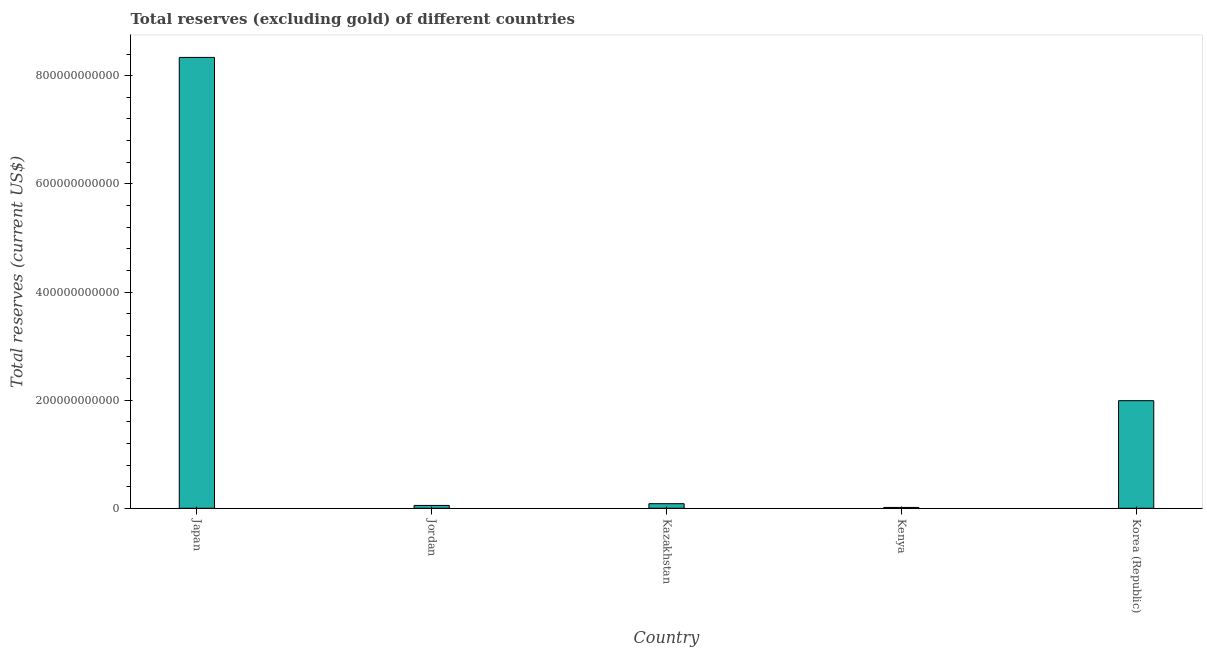Does the graph contain any zero values?
Provide a short and direct response. No. What is the title of the graph?
Offer a very short reply. Total reserves (excluding gold) of different countries. What is the label or title of the X-axis?
Provide a short and direct response. Country. What is the label or title of the Y-axis?
Offer a very short reply. Total reserves (current US$). What is the total reserves (excluding gold) in Jordan?
Make the answer very short. 5.27e+09. Across all countries, what is the maximum total reserves (excluding gold)?
Provide a short and direct response. 8.34e+11. Across all countries, what is the minimum total reserves (excluding gold)?
Offer a very short reply. 1.52e+09. In which country was the total reserves (excluding gold) minimum?
Your answer should be compact. Kenya. What is the sum of the total reserves (excluding gold)?
Provide a succinct answer. 1.05e+12. What is the difference between the total reserves (excluding gold) in Kazakhstan and Korea (Republic)?
Make the answer very short. -1.91e+11. What is the average total reserves (excluding gold) per country?
Give a very brief answer. 2.10e+11. What is the median total reserves (excluding gold)?
Give a very brief answer. 8.47e+09. In how many countries, is the total reserves (excluding gold) greater than 40000000000 US$?
Keep it short and to the point. 2. What is the ratio of the total reserves (excluding gold) in Kazakhstan to that in Korea (Republic)?
Provide a succinct answer. 0.04. What is the difference between the highest and the second highest total reserves (excluding gold)?
Keep it short and to the point. 6.35e+11. What is the difference between the highest and the lowest total reserves (excluding gold)?
Make the answer very short. 8.32e+11. How many bars are there?
Keep it short and to the point. 5. Are all the bars in the graph horizontal?
Make the answer very short. No. How many countries are there in the graph?
Offer a very short reply. 5. What is the difference between two consecutive major ticks on the Y-axis?
Your response must be concise. 2.00e+11. Are the values on the major ticks of Y-axis written in scientific E-notation?
Keep it short and to the point. No. What is the Total reserves (current US$) of Japan?
Give a very brief answer. 8.34e+11. What is the Total reserves (current US$) of Jordan?
Your answer should be compact. 5.27e+09. What is the Total reserves (current US$) of Kazakhstan?
Give a very brief answer. 8.47e+09. What is the Total reserves (current US$) in Kenya?
Provide a short and direct response. 1.52e+09. What is the Total reserves (current US$) in Korea (Republic)?
Offer a terse response. 1.99e+11. What is the difference between the Total reserves (current US$) in Japan and Jordan?
Keep it short and to the point. 8.29e+11. What is the difference between the Total reserves (current US$) in Japan and Kazakhstan?
Provide a succinct answer. 8.25e+11. What is the difference between the Total reserves (current US$) in Japan and Kenya?
Keep it short and to the point. 8.32e+11. What is the difference between the Total reserves (current US$) in Japan and Korea (Republic)?
Offer a terse response. 6.35e+11. What is the difference between the Total reserves (current US$) in Jordan and Kazakhstan?
Give a very brief answer. -3.21e+09. What is the difference between the Total reserves (current US$) in Jordan and Kenya?
Provide a succinct answer. 3.75e+09. What is the difference between the Total reserves (current US$) in Jordan and Korea (Republic)?
Your response must be concise. -1.94e+11. What is the difference between the Total reserves (current US$) in Kazakhstan and Kenya?
Offer a terse response. 6.95e+09. What is the difference between the Total reserves (current US$) in Kazakhstan and Korea (Republic)?
Offer a very short reply. -1.91e+11. What is the difference between the Total reserves (current US$) in Kenya and Korea (Republic)?
Your answer should be very brief. -1.97e+11. What is the ratio of the Total reserves (current US$) in Japan to that in Jordan?
Your answer should be very brief. 158.34. What is the ratio of the Total reserves (current US$) in Japan to that in Kazakhstan?
Make the answer very short. 98.42. What is the ratio of the Total reserves (current US$) in Japan to that in Kenya?
Keep it short and to the point. 548.86. What is the ratio of the Total reserves (current US$) in Japan to that in Korea (Republic)?
Your answer should be compact. 4.19. What is the ratio of the Total reserves (current US$) in Jordan to that in Kazakhstan?
Your answer should be compact. 0.62. What is the ratio of the Total reserves (current US$) in Jordan to that in Kenya?
Give a very brief answer. 3.47. What is the ratio of the Total reserves (current US$) in Jordan to that in Korea (Republic)?
Make the answer very short. 0.03. What is the ratio of the Total reserves (current US$) in Kazakhstan to that in Kenya?
Ensure brevity in your answer.  5.58. What is the ratio of the Total reserves (current US$) in Kazakhstan to that in Korea (Republic)?
Give a very brief answer. 0.04. What is the ratio of the Total reserves (current US$) in Kenya to that in Korea (Republic)?
Provide a short and direct response. 0.01. 